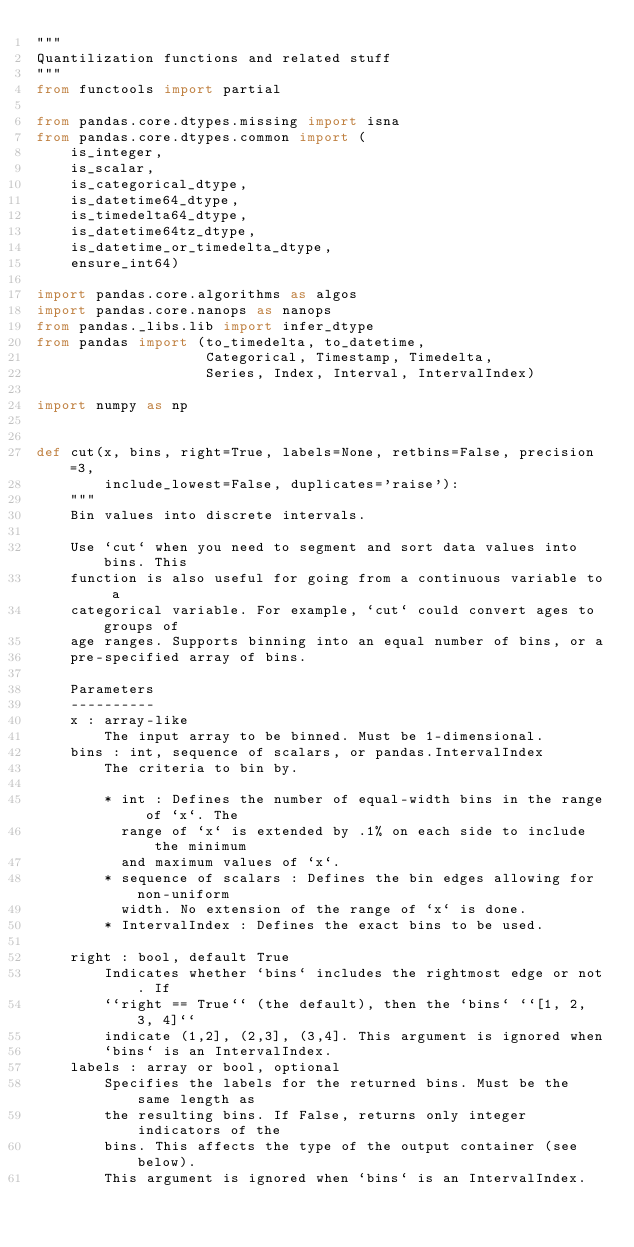Convert code to text. <code><loc_0><loc_0><loc_500><loc_500><_Python_>"""
Quantilization functions and related stuff
"""
from functools import partial

from pandas.core.dtypes.missing import isna
from pandas.core.dtypes.common import (
    is_integer,
    is_scalar,
    is_categorical_dtype,
    is_datetime64_dtype,
    is_timedelta64_dtype,
    is_datetime64tz_dtype,
    is_datetime_or_timedelta_dtype,
    ensure_int64)

import pandas.core.algorithms as algos
import pandas.core.nanops as nanops
from pandas._libs.lib import infer_dtype
from pandas import (to_timedelta, to_datetime,
                    Categorical, Timestamp, Timedelta,
                    Series, Index, Interval, IntervalIndex)

import numpy as np


def cut(x, bins, right=True, labels=None, retbins=False, precision=3,
        include_lowest=False, duplicates='raise'):
    """
    Bin values into discrete intervals.

    Use `cut` when you need to segment and sort data values into bins. This
    function is also useful for going from a continuous variable to a
    categorical variable. For example, `cut` could convert ages to groups of
    age ranges. Supports binning into an equal number of bins, or a
    pre-specified array of bins.

    Parameters
    ----------
    x : array-like
        The input array to be binned. Must be 1-dimensional.
    bins : int, sequence of scalars, or pandas.IntervalIndex
        The criteria to bin by.

        * int : Defines the number of equal-width bins in the range of `x`. The
          range of `x` is extended by .1% on each side to include the minimum
          and maximum values of `x`.
        * sequence of scalars : Defines the bin edges allowing for non-uniform
          width. No extension of the range of `x` is done.
        * IntervalIndex : Defines the exact bins to be used.

    right : bool, default True
        Indicates whether `bins` includes the rightmost edge or not. If
        ``right == True`` (the default), then the `bins` ``[1, 2, 3, 4]``
        indicate (1,2], (2,3], (3,4]. This argument is ignored when
        `bins` is an IntervalIndex.
    labels : array or bool, optional
        Specifies the labels for the returned bins. Must be the same length as
        the resulting bins. If False, returns only integer indicators of the
        bins. This affects the type of the output container (see below).
        This argument is ignored when `bins` is an IntervalIndex.</code> 